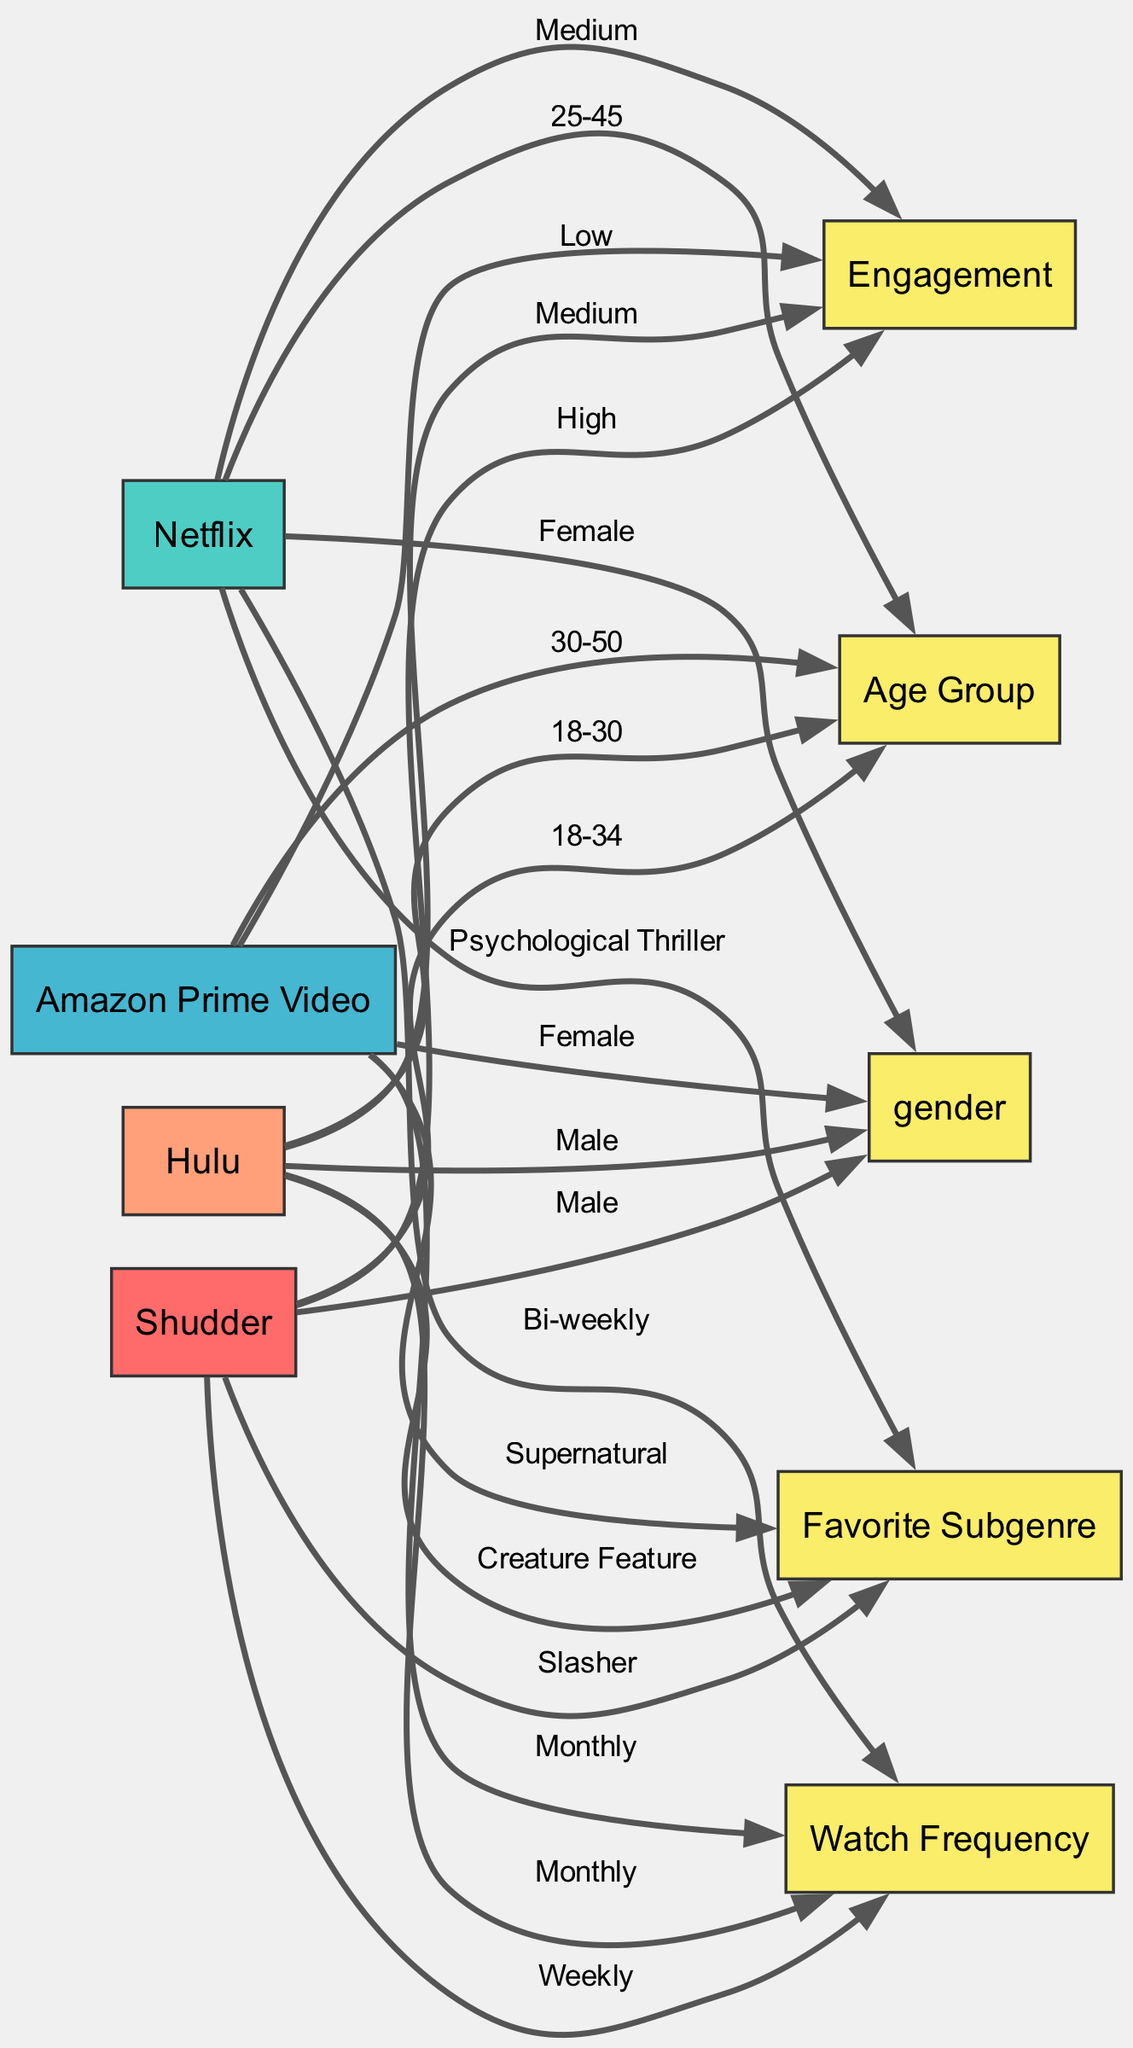What is the engagement level of viewers on Shudder? The diagram shows an edge leading from the Shudder platform to the engagement level node, labeled "High." This indicates that Shudder has a high level of viewer engagement.
Answer: High Which platform has viewers in the age group 30-50? By following the edge from the platform nodes to the age group node, we see that Amazon Prime Video connects to the "30-50" age group, indicating this is the demographic for that platform.
Answer: Amazon Prime Video How often do viewers watch movies on Netflix? There is a link from the Netflix platform node to the watch frequency node, labeled "Bi-weekly." This label describes how frequently users of Netflix engage with watching movies.
Answer: Bi-weekly What is the favorite subgenre of Shudder viewers? The diagram shows an edge from Shudder to the favorite subgenre node, labeled "Slasher." This label designates the specific subgenre preference of the audience on that platform.
Answer: Slasher Which demographic category has the least number of nodes connected to it? The viewer preferences for favorite subgenre and watch frequency contain two edges each, while the demographic category for engagement level represents only one flow. Given this, the edge count shows that engagement level has the least connections.
Answer: engagement level What gender demographic is most engaged on Hulu? The detail shows an edge from Hulu to the gender demographic node, indicating "Male." This means that the male demographic is prominent among viewers engaged on that platform.
Answer: Male How many platforms offer monthly viewing frequency? Examining the watch frequency connections, both Amazon Prime Video and Hulu are linked to the label "Monthly." Therefore, there are two platforms identified with this frequency of viewing.
Answer: 2 What is the favorite subgenre for viewers on Amazon Prime Video? Following the edge from Amazon Prime Video to the subgenre node, it is labeled "Supernatural." This label defines what subgenre resonates most with its audience specifically.
Answer: Supernatural Which platform has a higher engagement level: Hulu or Netflix? The diagram indicates Netflix has a "Medium" engagement level while Hulu has the same engagement level labeled as "Medium." Therefore, they are at similar levels in terms of viewer engagement.
Answer: Equal 